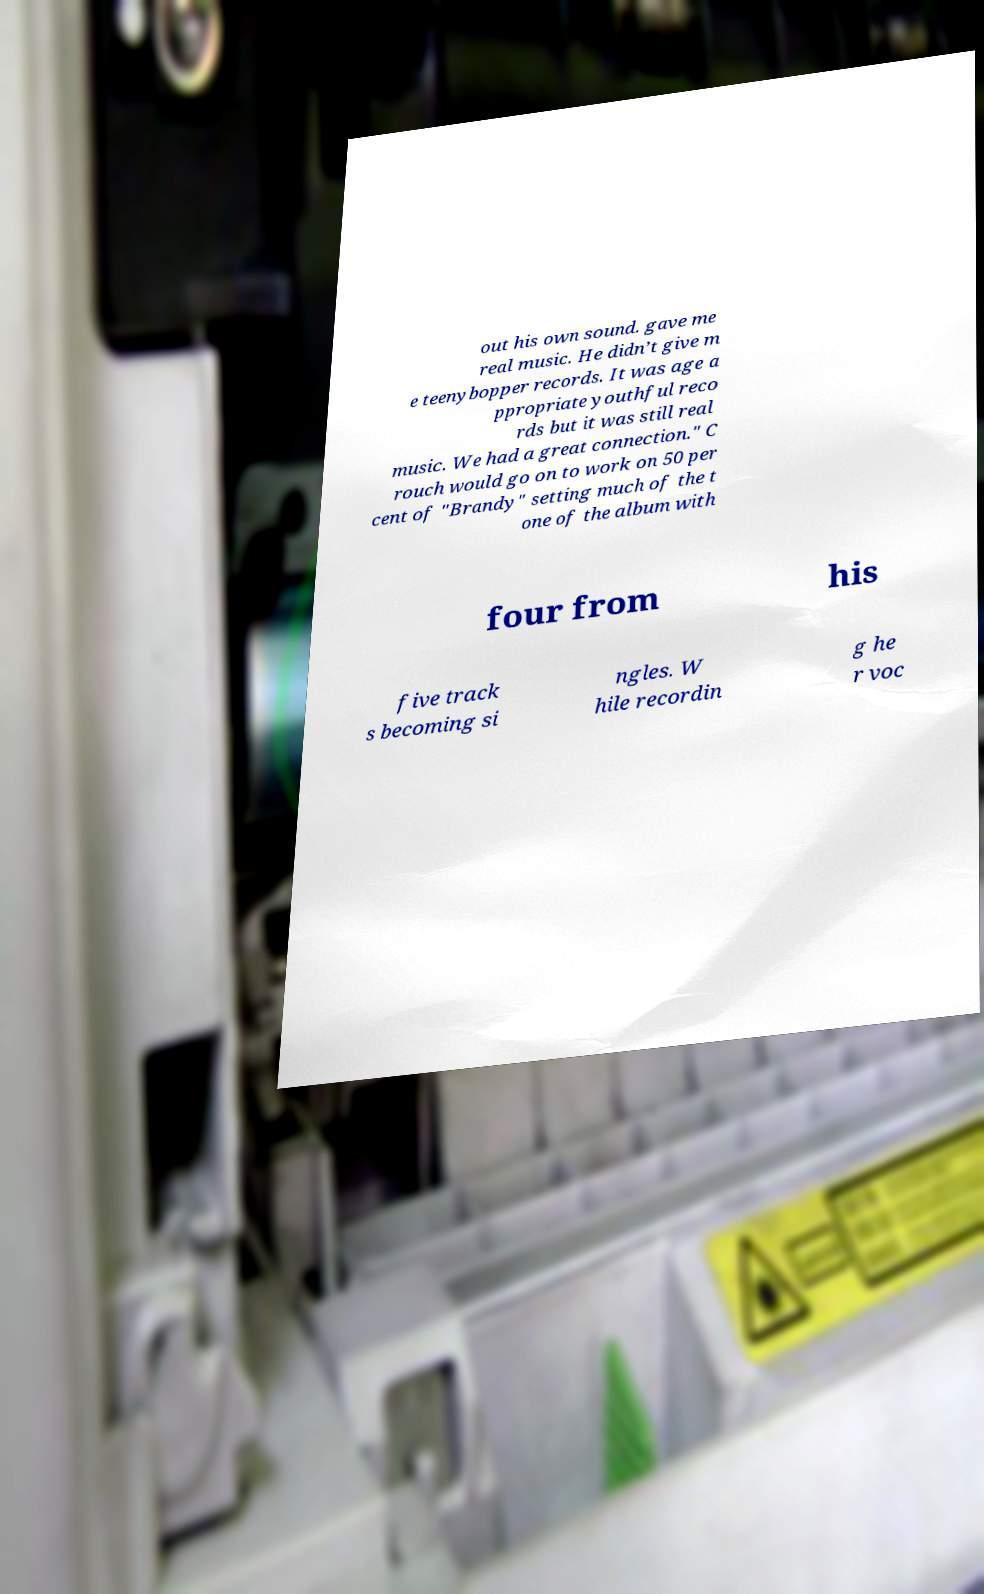Could you assist in decoding the text presented in this image and type it out clearly? out his own sound. gave me real music. He didn’t give m e teenybopper records. It was age a ppropriate youthful reco rds but it was still real music. We had a great connection." C rouch would go on to work on 50 per cent of "Brandy" setting much of the t one of the album with four from his five track s becoming si ngles. W hile recordin g he r voc 